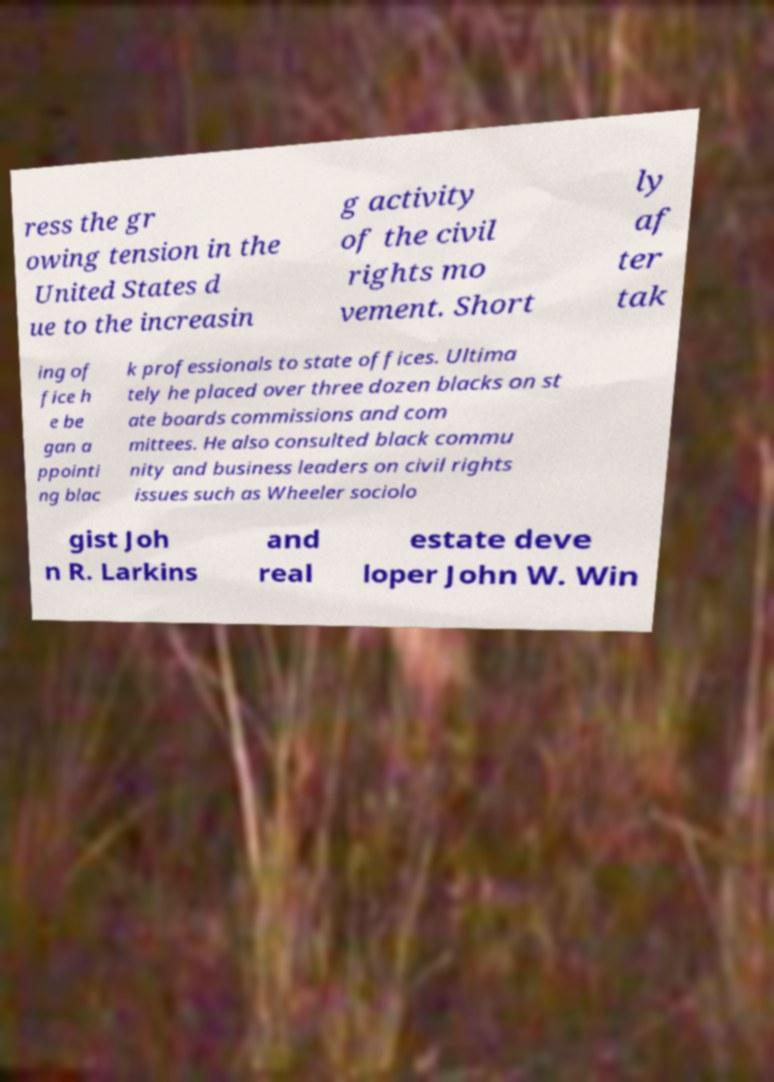There's text embedded in this image that I need extracted. Can you transcribe it verbatim? ress the gr owing tension in the United States d ue to the increasin g activity of the civil rights mo vement. Short ly af ter tak ing of fice h e be gan a ppointi ng blac k professionals to state offices. Ultima tely he placed over three dozen blacks on st ate boards commissions and com mittees. He also consulted black commu nity and business leaders on civil rights issues such as Wheeler sociolo gist Joh n R. Larkins and real estate deve loper John W. Win 